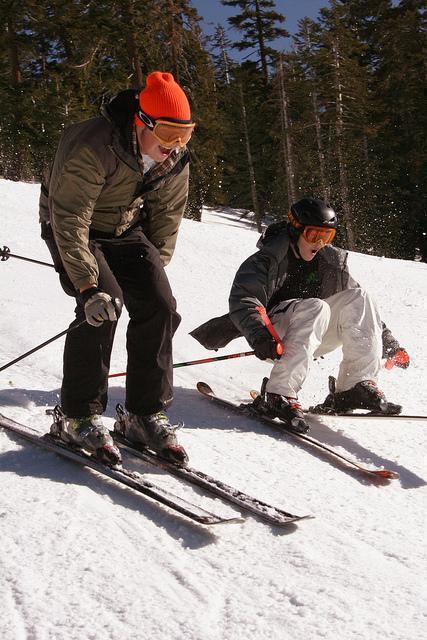How many people are there?
Give a very brief answer. 2. How many ski can be seen?
Give a very brief answer. 2. 